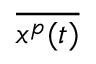<formula> <loc_0><loc_0><loc_500><loc_500>\overline { { x ^ { p } ( t ) } }</formula> 